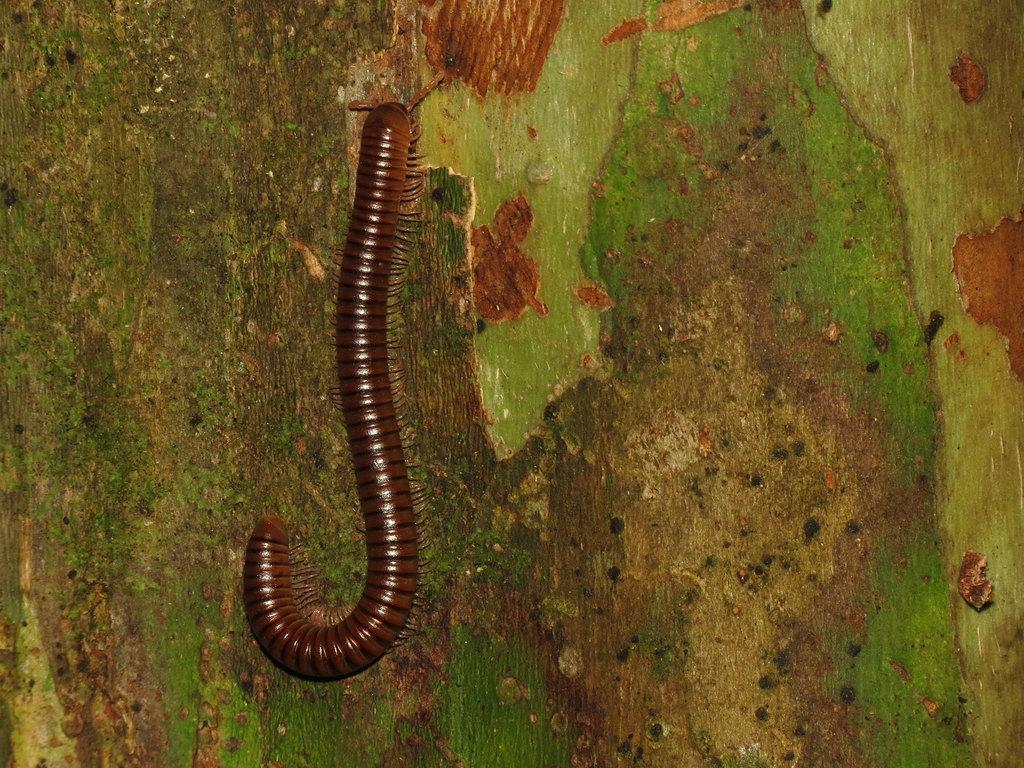How would you summarize this image in a sentence or two? On this wooden surface we can see an insect. 